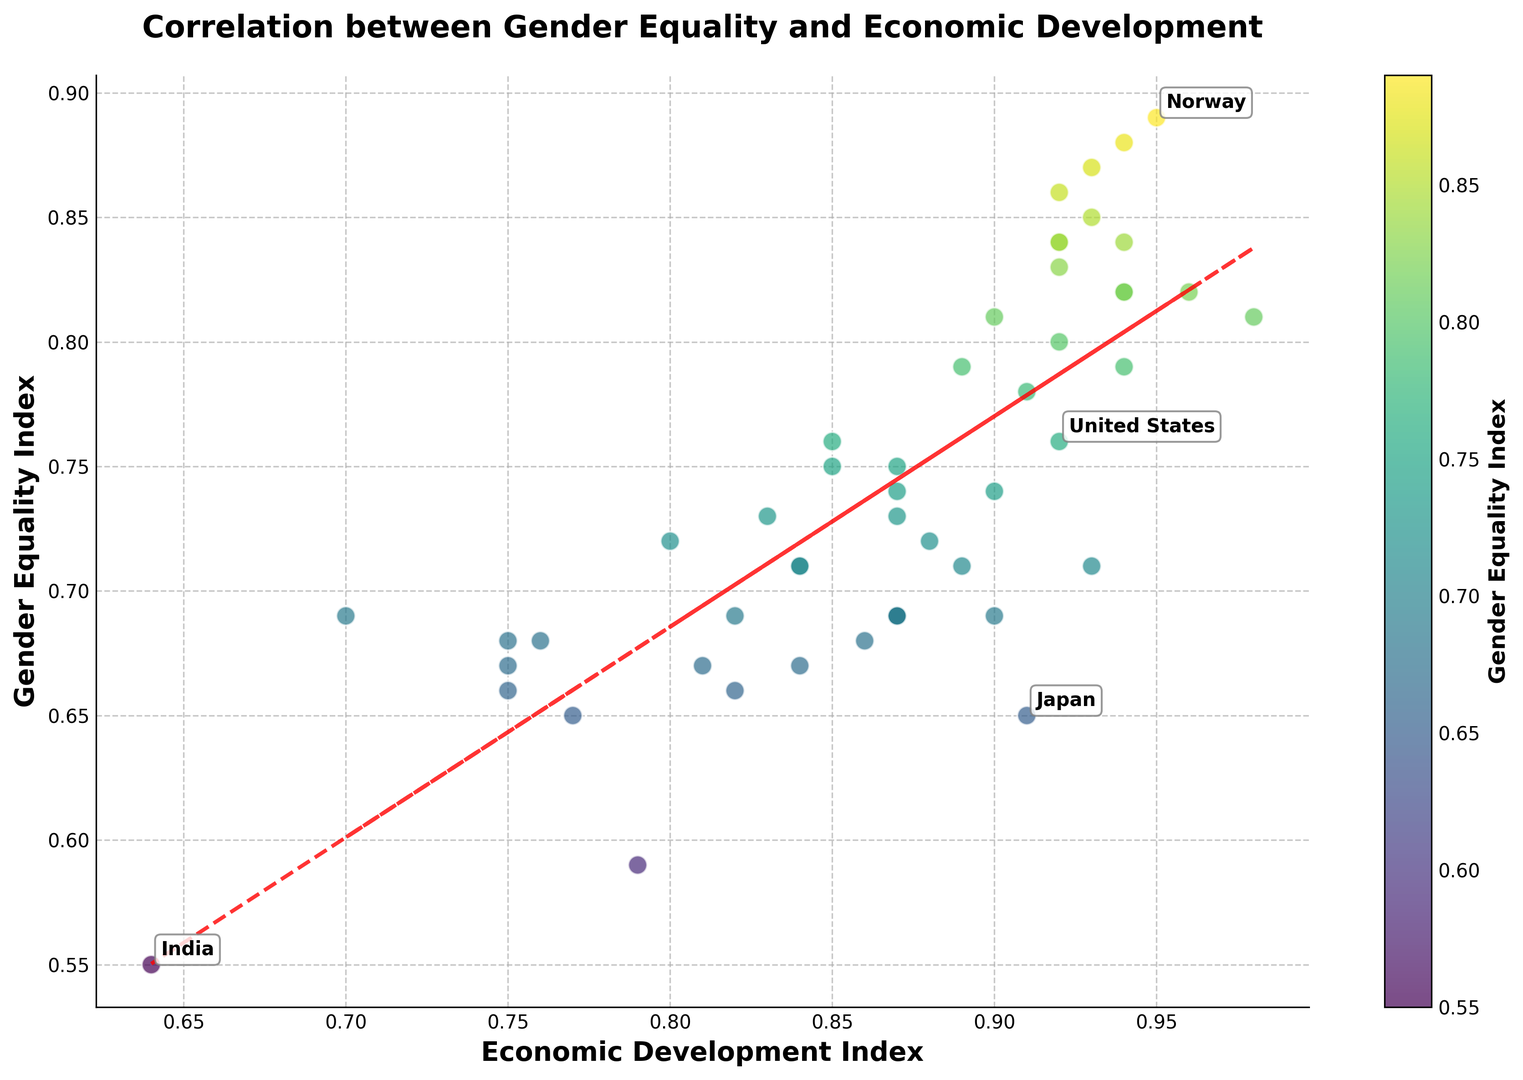What is the general trend between the Gender Equality Index and the Economic Development Index? By looking at the overall pattern in the scatter plot, we observe that there is a positive correlation trend line. As the Economic Development Index increases, the Gender Equality Index also tends to increase.
Answer: Positive correlation Which country has the highest Gender Equality Index? The highest point on the y-axis (Gender Equality Index) identified by the color bar corresponds to Norway, with a Gender Equality Index of 0.89.
Answer: Norway Do higher levels of economic development usually correlate with higher gender equality? By observing the trend line and scattered points, there's a visible positive correlation between higher values on the Economic Development Index and higher gender equality, indicating that generally higher economic development correlates with higher gender equality.
Answer: Yes Which country is an outlier with high economic development but relatively lower gender equality? Japan stands out as an outlier with a high Economic Development Index around 0.91 but a relatively low Gender Equality Index of 0.65, which is lower than expected given its economic development level.
Answer: Japan Compare gender equality levels between Norway and Japan. Which country has a higher Gender Equality Index and by how much? Norway has a Gender Equality Index of 0.89 while Japan has 0.65. The difference is 0.89 - 0.65 = 0.24.
Answer: Norway by 0.24 Which countries have almost equal levels of economic development as the United States but different gender equality levels? The United States has an Economic Development Index of 0.92. Other countries with similar economic development levels are Germany and Ireland. Germany has a Gender Equality Index of 0.82, while Ireland has a Gender Equality Index of 0.79.
Answer: Germany and Ireland What is the relationship between the color of the data points and the Gender Equality Index? The color of the data points, following a viridis colormap, shows that lighter colors represent higher Gender Equality Index values and darker colors represent lower values. This can be seen with countries like Norway (lighter) and India (darker).
Answer: Lighter color indicates higher gender equality How does the Gender Equality Index of Denmark compare to that of Italy? Denmark has a Gender Equality Index of 0.85, while Italy has 0.73. Therefore, Denmark's Gender Equality Index is higher by 0.12.
Answer: Denmark by 0.12 What is the combined Economic Development Index of Portugal and Spain? Portugal's Economic Development Index is 0.85, and Spain's is 0.89. The sum is 0.85 + 0.89 = 1.74.
Answer: 1.74 Identify the country with a significant difference between GDP and Gender Equality Index around mid-range levels. South Korea has a mid-range Gender Equality Index of 0.69, yet it displays a relatively high Economic Development Index of 0.90, indicating a significant disparity.
Answer: South Korea 